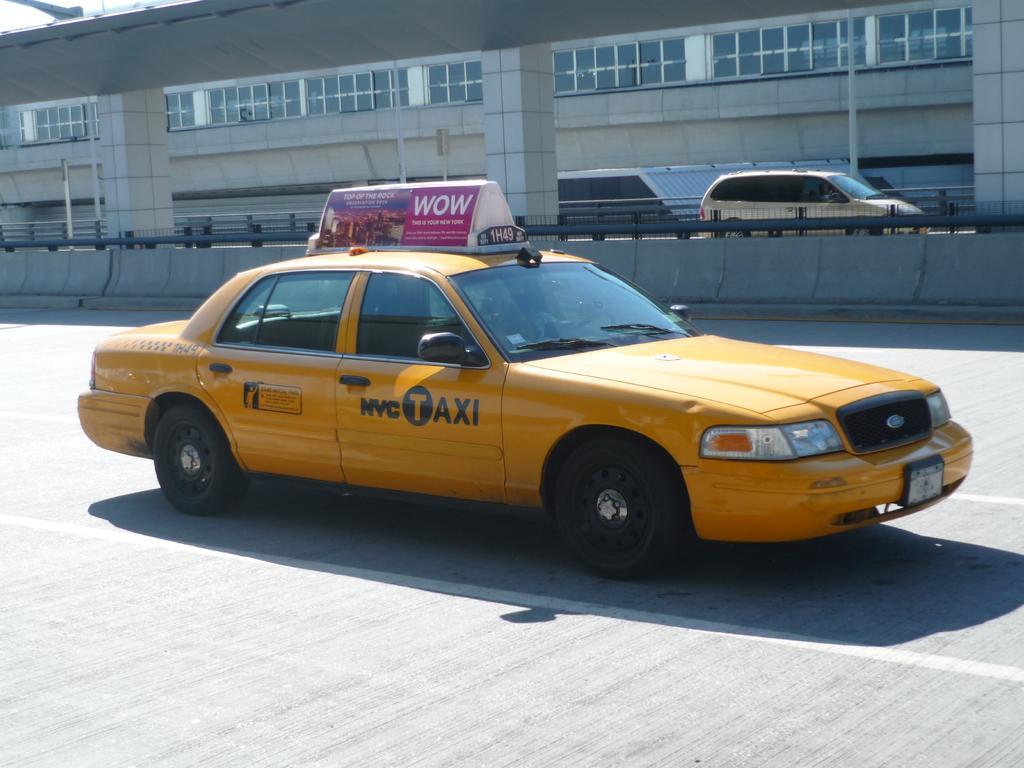Can you describe this image briefly? In the picture we can see a taxi which is yellow in color and some board on top of it and beside it, we can see a railing and a fly over with pillars and under it we can see some cars and beside it we can see a building with a glass window. 